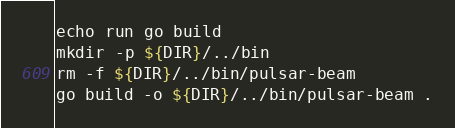Convert code to text. <code><loc_0><loc_0><loc_500><loc_500><_Bash_>
echo run go build
mkdir -p ${DIR}/../bin
rm -f ${DIR}/../bin/pulsar-beam
go build -o ${DIR}/../bin/pulsar-beam .
</code> 